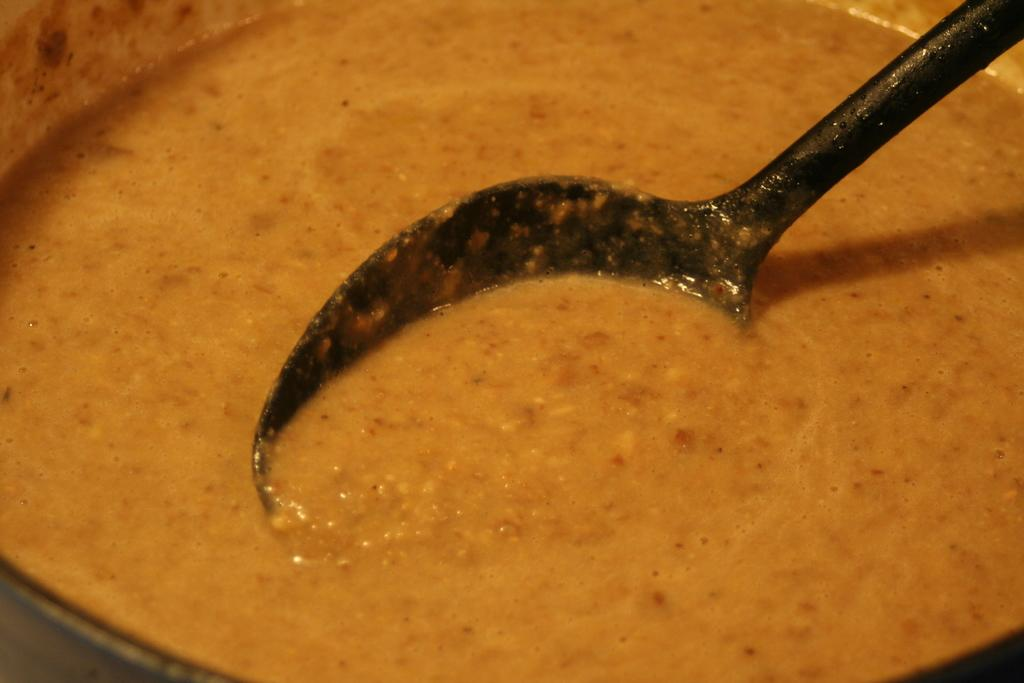What is in the bowl that is visible in the image? There is a bowl with food in the image. What color is the spoon that is in the bowl? There is a black-colored spoon in the bowl. What type of bone can be seen in the image? There is no bone present in the image; it features a bowl with food and a black-colored spoon. What type of flight is depicted in the image? There is no flight depicted in the image; it features a bowl with food and a black-colored spoon. 